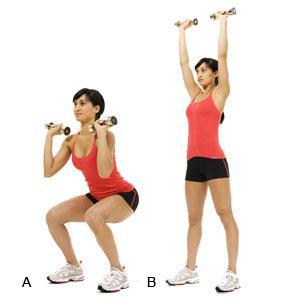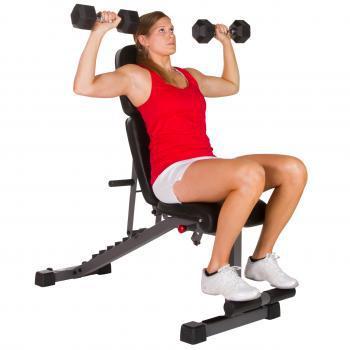The first image is the image on the left, the second image is the image on the right. Given the left and right images, does the statement "One of the images contains a woman sitting on fitness equipment." hold true? Answer yes or no. Yes. 